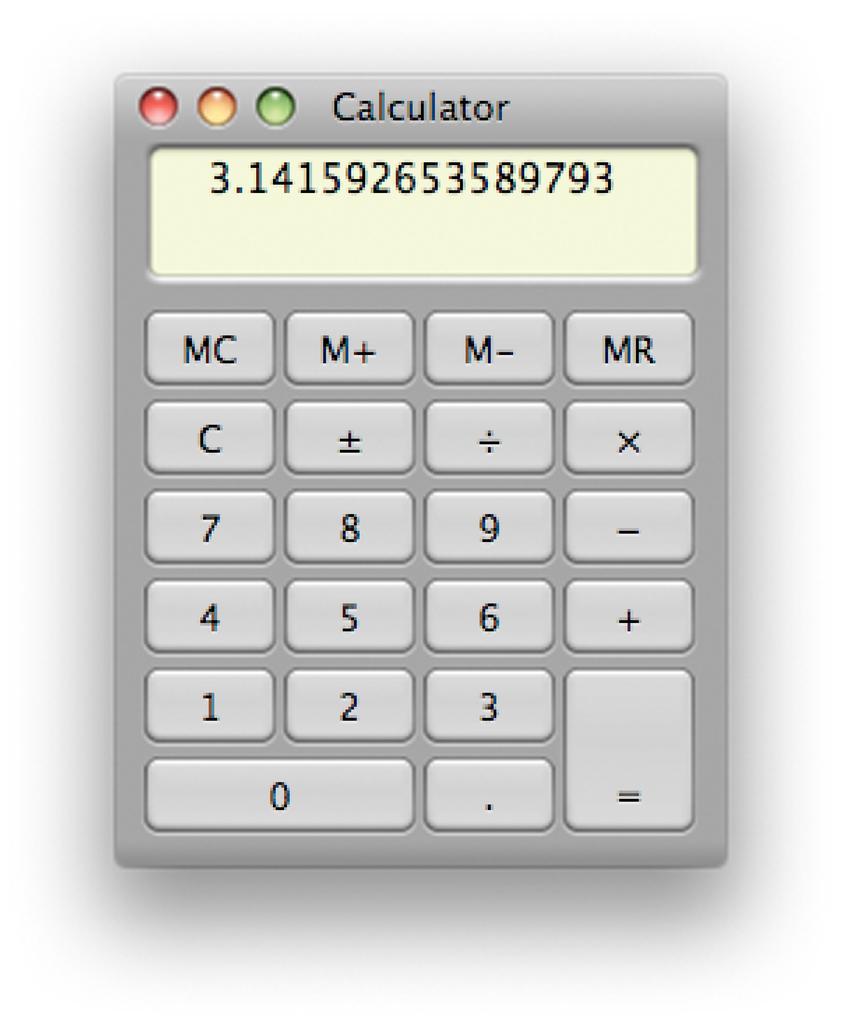What's the first 7 digits of the number on the calculator?
Ensure brevity in your answer.  3.141592. What are the last four numbers displayed?
Offer a very short reply. 9793. 